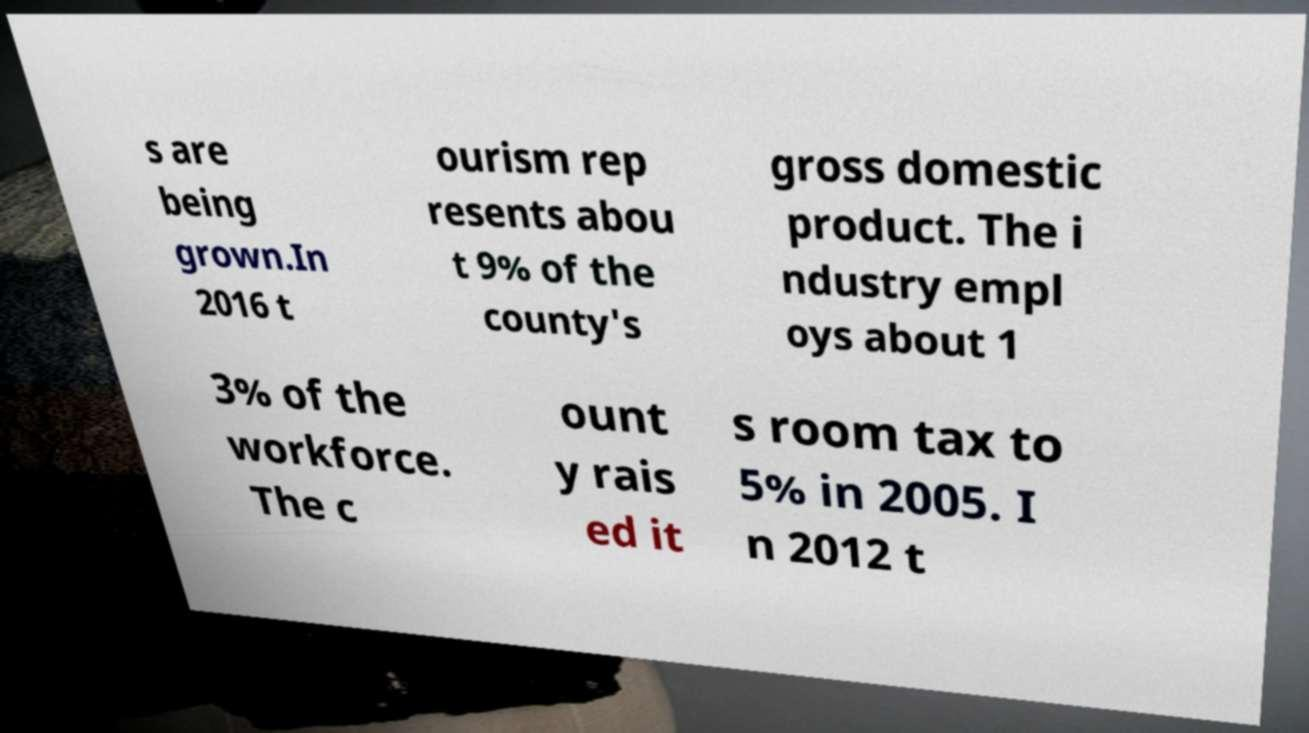Could you extract and type out the text from this image? s are being grown.In 2016 t ourism rep resents abou t 9% of the county's gross domestic product. The i ndustry empl oys about 1 3% of the workforce. The c ount y rais ed it s room tax to 5% in 2005. I n 2012 t 